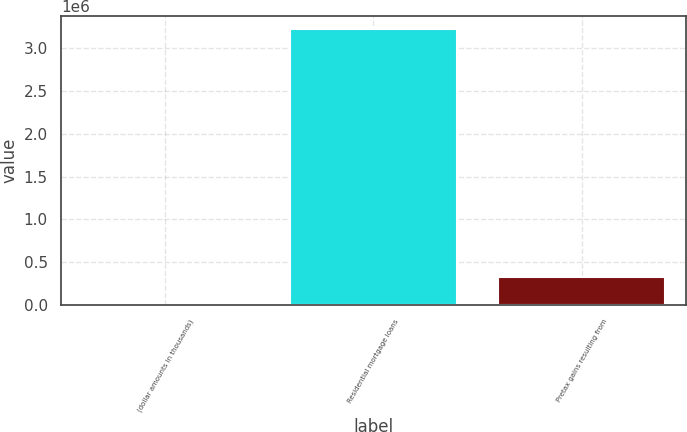<chart> <loc_0><loc_0><loc_500><loc_500><bar_chart><fcel>(dollar amounts in thousands)<fcel>Residential mortgage loans<fcel>Pretax gains resulting from<nl><fcel>2013<fcel>3.22124e+06<fcel>323936<nl></chart> 